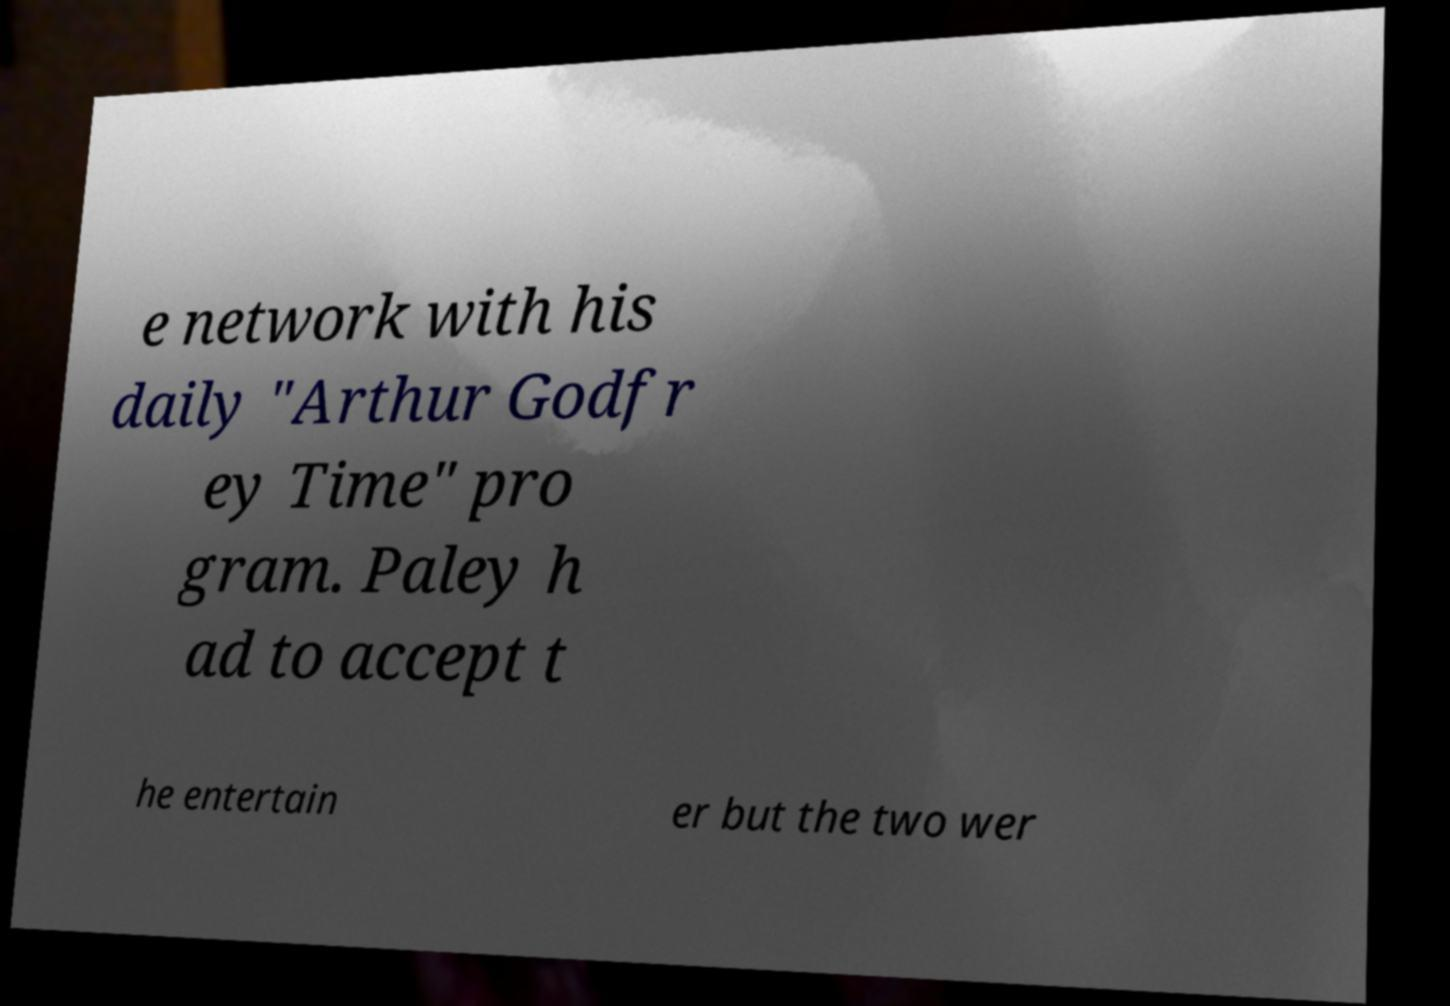I need the written content from this picture converted into text. Can you do that? e network with his daily "Arthur Godfr ey Time" pro gram. Paley h ad to accept t he entertain er but the two wer 